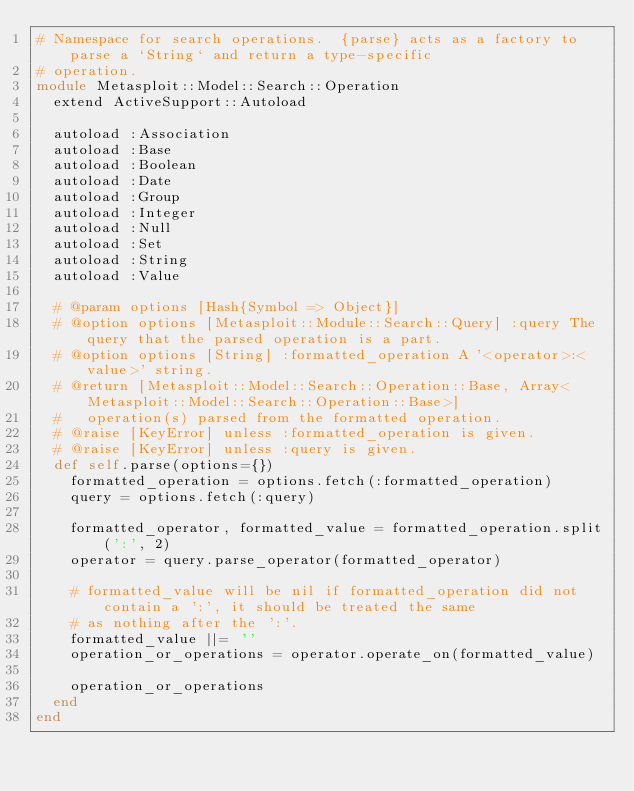Convert code to text. <code><loc_0><loc_0><loc_500><loc_500><_Ruby_># Namespace for search operations.  {parse} acts as a factory to parse a `String` and return a type-specific
# operation.
module Metasploit::Model::Search::Operation
  extend ActiveSupport::Autoload

  autoload :Association
  autoload :Base
  autoload :Boolean
  autoload :Date
  autoload :Group
  autoload :Integer
  autoload :Null
  autoload :Set
  autoload :String
  autoload :Value

  # @param options [Hash{Symbol => Object}]
  # @option options [Metasploit::Module::Search::Query] :query The query that the parsed operation is a part.
  # @option options [String] :formatted_operation A '<operator>:<value>' string.
  # @return [Metasploit::Model::Search::Operation::Base, Array<Metasploit::Model::Search::Operation::Base>]
  #   operation(s) parsed from the formatted operation.
  # @raise [KeyError] unless :formatted_operation is given.
  # @raise [KeyError] unless :query is given.
  def self.parse(options={})
    formatted_operation = options.fetch(:formatted_operation)
    query = options.fetch(:query)

    formatted_operator, formatted_value = formatted_operation.split(':', 2)
    operator = query.parse_operator(formatted_operator)

    # formatted_value will be nil if formatted_operation did not contain a ':', it should be treated the same
    # as nothing after the ':'.
    formatted_value ||= ''
    operation_or_operations = operator.operate_on(formatted_value)

    operation_or_operations
  end
end
</code> 